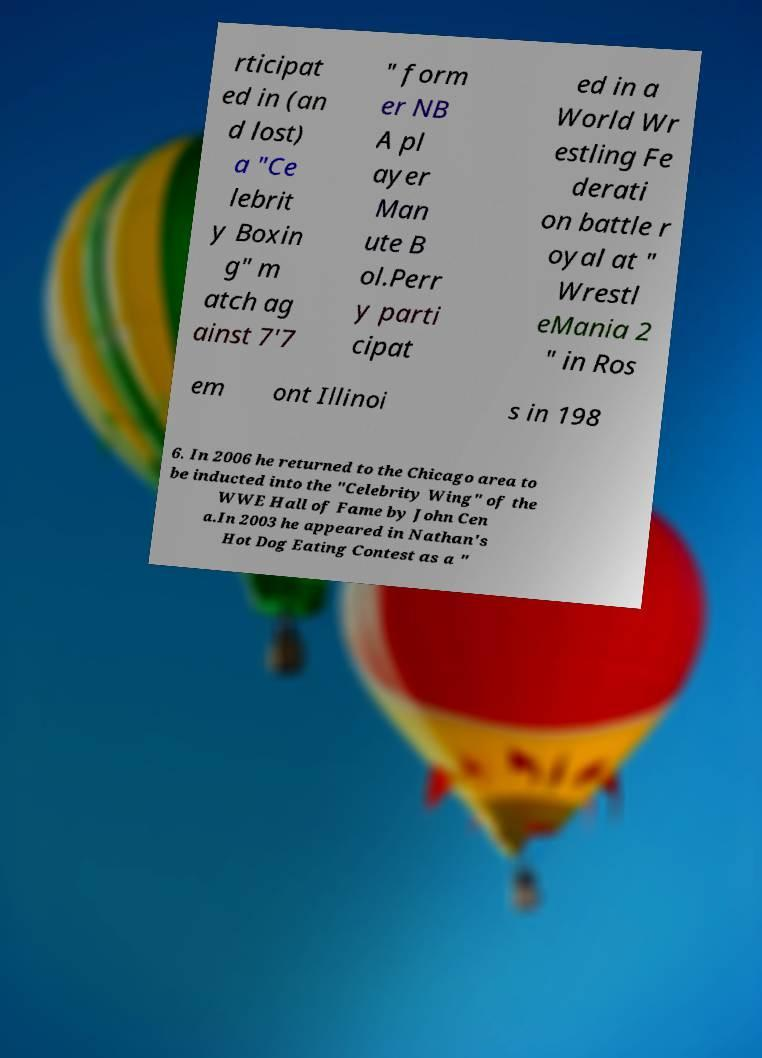Could you assist in decoding the text presented in this image and type it out clearly? rticipat ed in (an d lost) a "Ce lebrit y Boxin g" m atch ag ainst 7'7 " form er NB A pl ayer Man ute B ol.Perr y parti cipat ed in a World Wr estling Fe derati on battle r oyal at " Wrestl eMania 2 " in Ros em ont Illinoi s in 198 6. In 2006 he returned to the Chicago area to be inducted into the "Celebrity Wing" of the WWE Hall of Fame by John Cen a.In 2003 he appeared in Nathan's Hot Dog Eating Contest as a " 